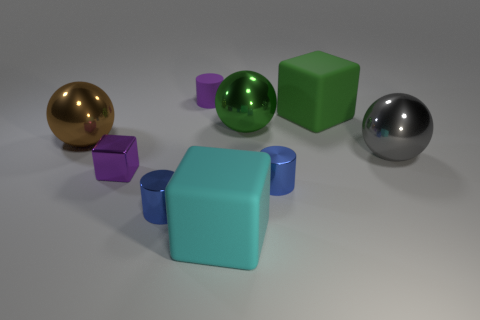Add 1 red metal blocks. How many objects exist? 10 Subtract all large gray metallic balls. How many balls are left? 2 Subtract all cyan balls. How many blue cylinders are left? 2 Subtract all gray spheres. How many spheres are left? 2 Subtract 2 cylinders. How many cylinders are left? 1 Subtract all yellow blocks. Subtract all red balls. How many blocks are left? 3 Subtract all metallic balls. Subtract all balls. How many objects are left? 3 Add 5 cylinders. How many cylinders are left? 8 Add 7 blue balls. How many blue balls exist? 7 Subtract 0 red spheres. How many objects are left? 9 